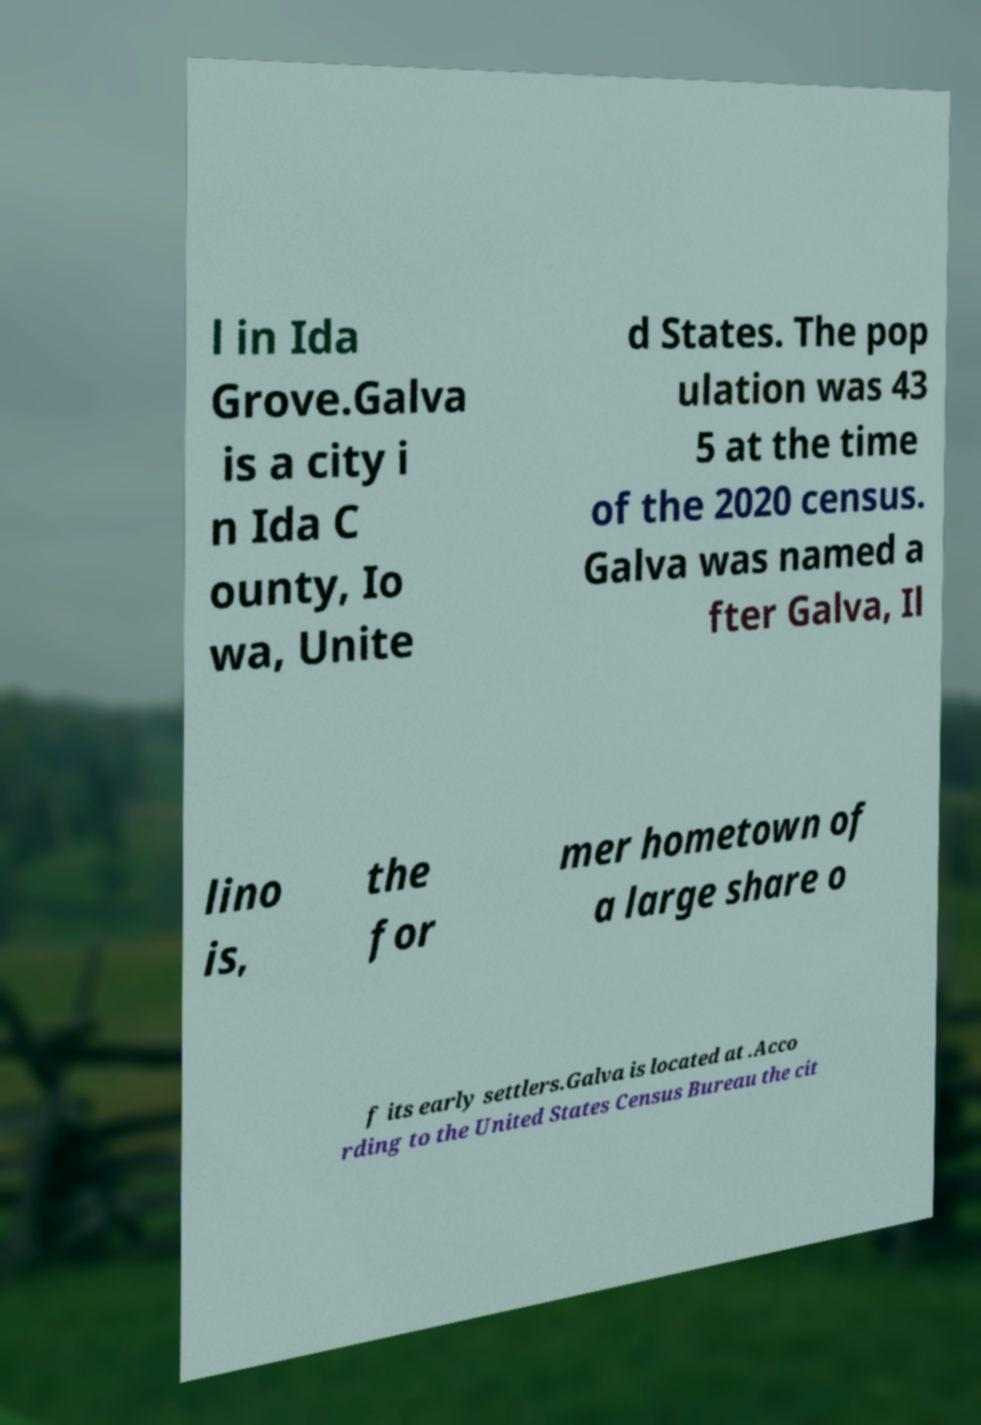Can you accurately transcribe the text from the provided image for me? l in Ida Grove.Galva is a city i n Ida C ounty, Io wa, Unite d States. The pop ulation was 43 5 at the time of the 2020 census. Galva was named a fter Galva, Il lino is, the for mer hometown of a large share o f its early settlers.Galva is located at .Acco rding to the United States Census Bureau the cit 